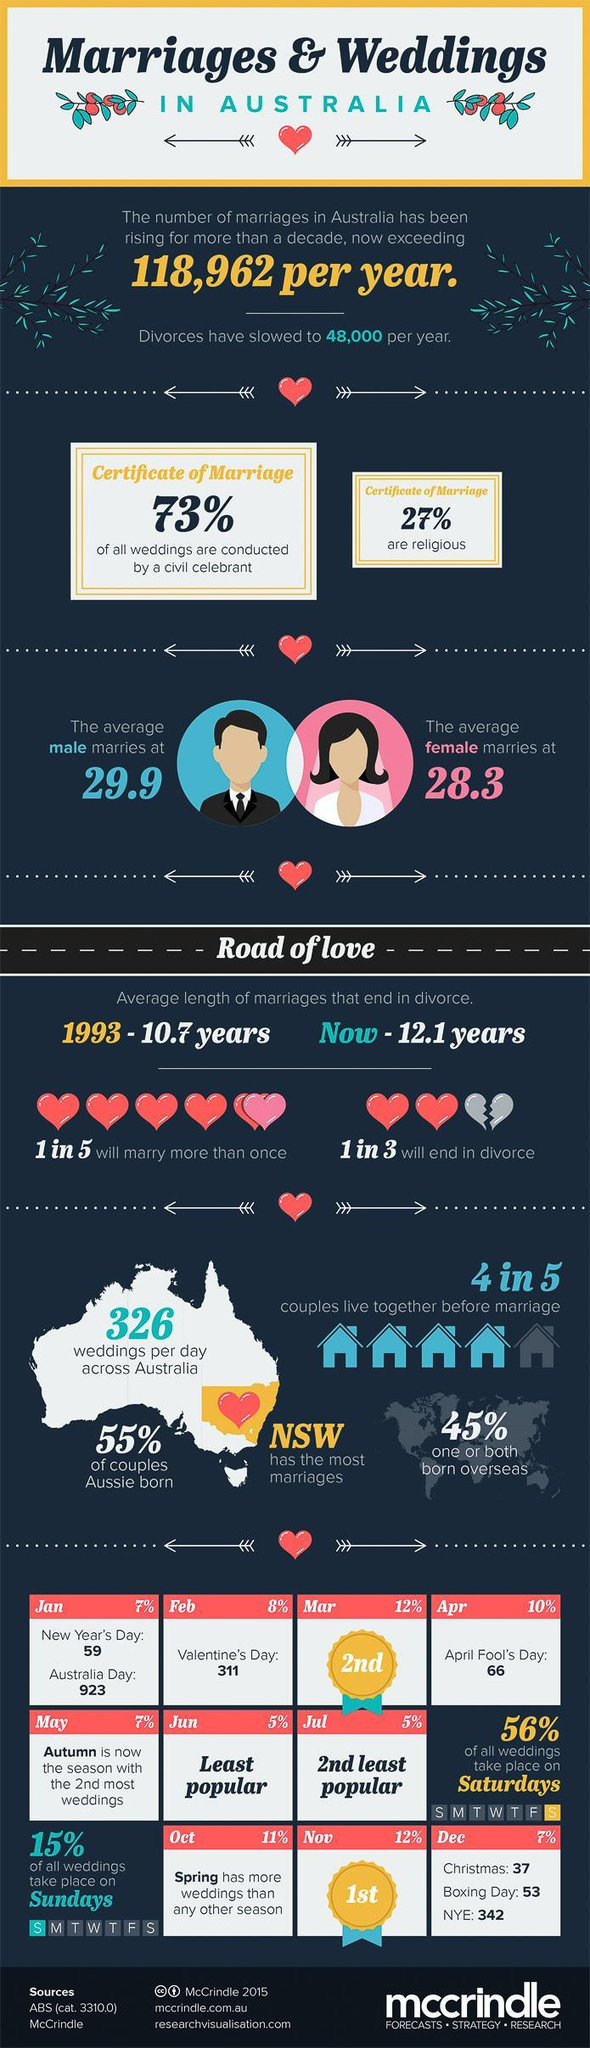What percentage of couples are not Aussie born?
Answer the question with a short phrase. 45% What percentage of weddings are not conducted by a civil celebrant? 27% What percentage of marriage certificates are non-religious? 73% Out of 5, how many will marry only once? 4 